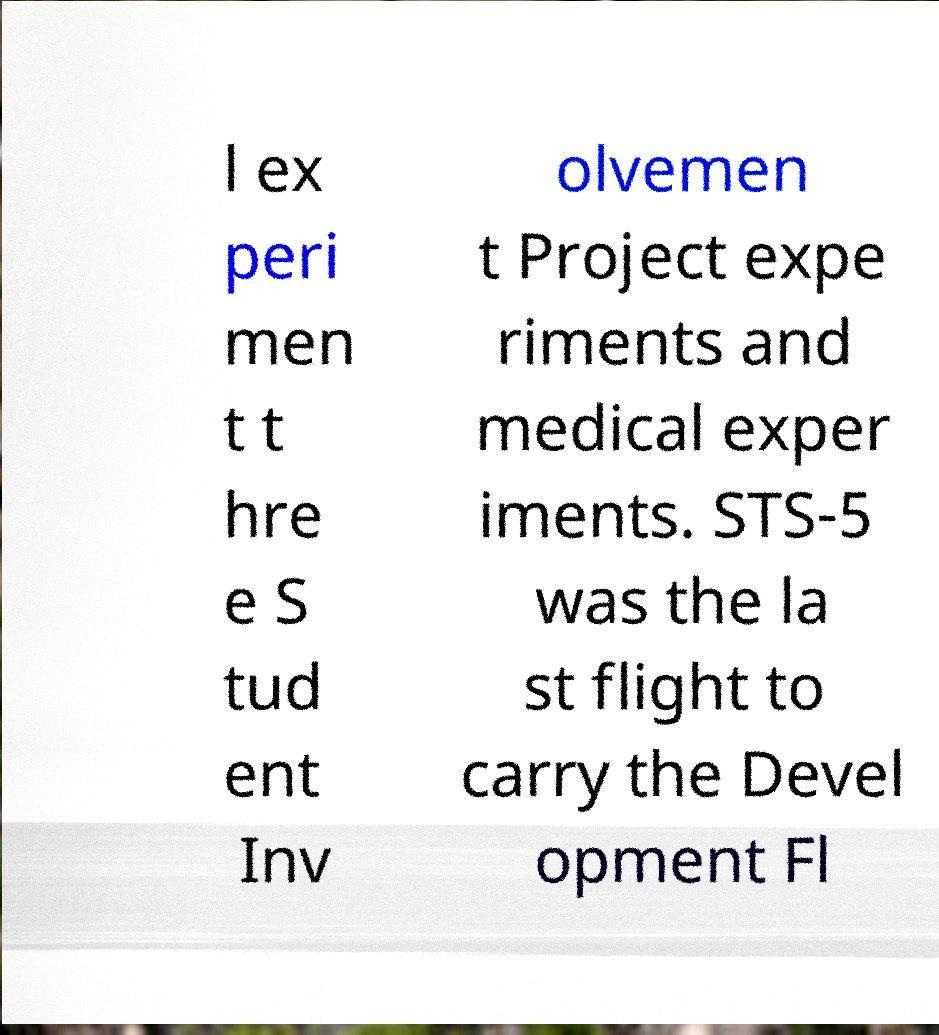Could you extract and type out the text from this image? l ex peri men t t hre e S tud ent Inv olvemen t Project expe riments and medical exper iments. STS-5 was the la st flight to carry the Devel opment Fl 